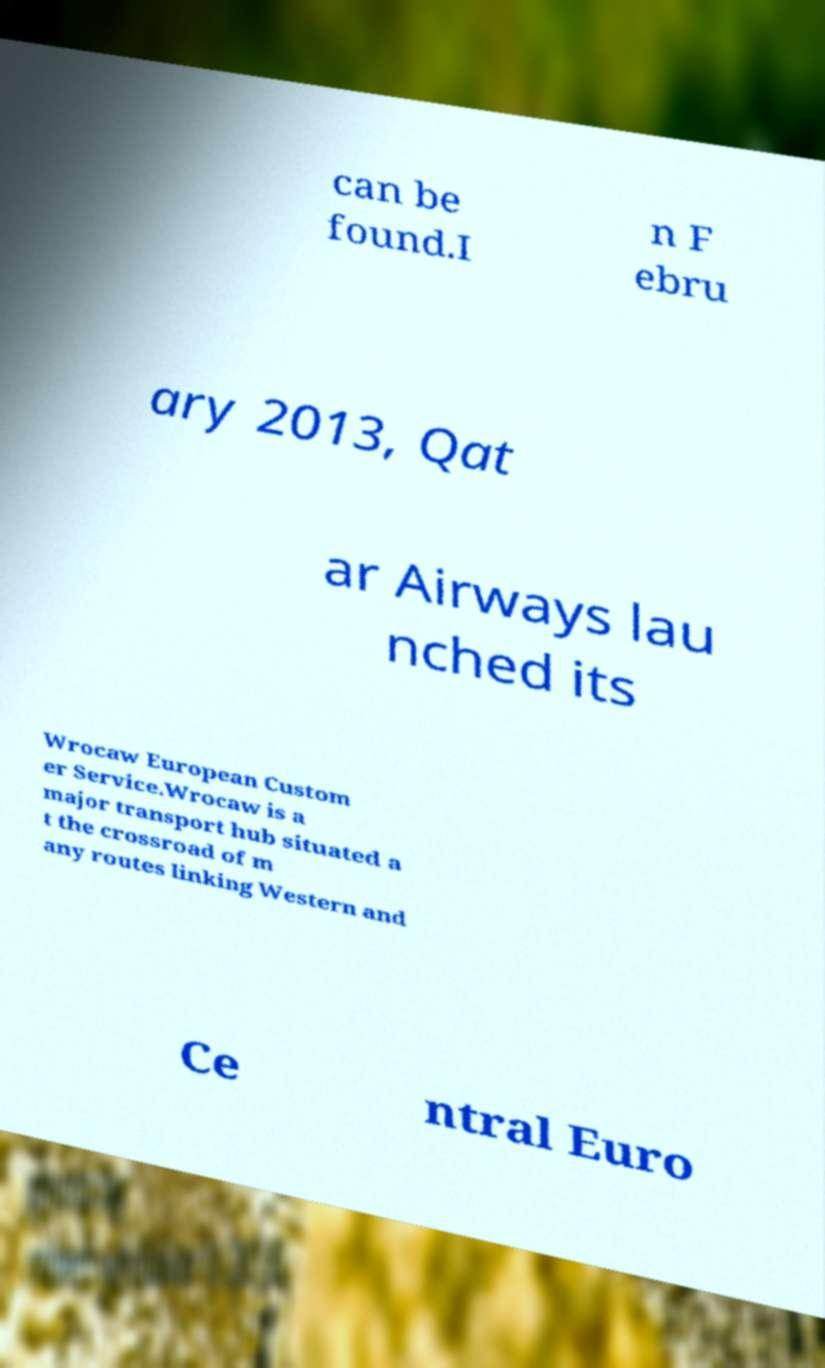There's text embedded in this image that I need extracted. Can you transcribe it verbatim? can be found.I n F ebru ary 2013, Qat ar Airways lau nched its Wrocaw European Custom er Service.Wrocaw is a major transport hub situated a t the crossroad of m any routes linking Western and Ce ntral Euro 